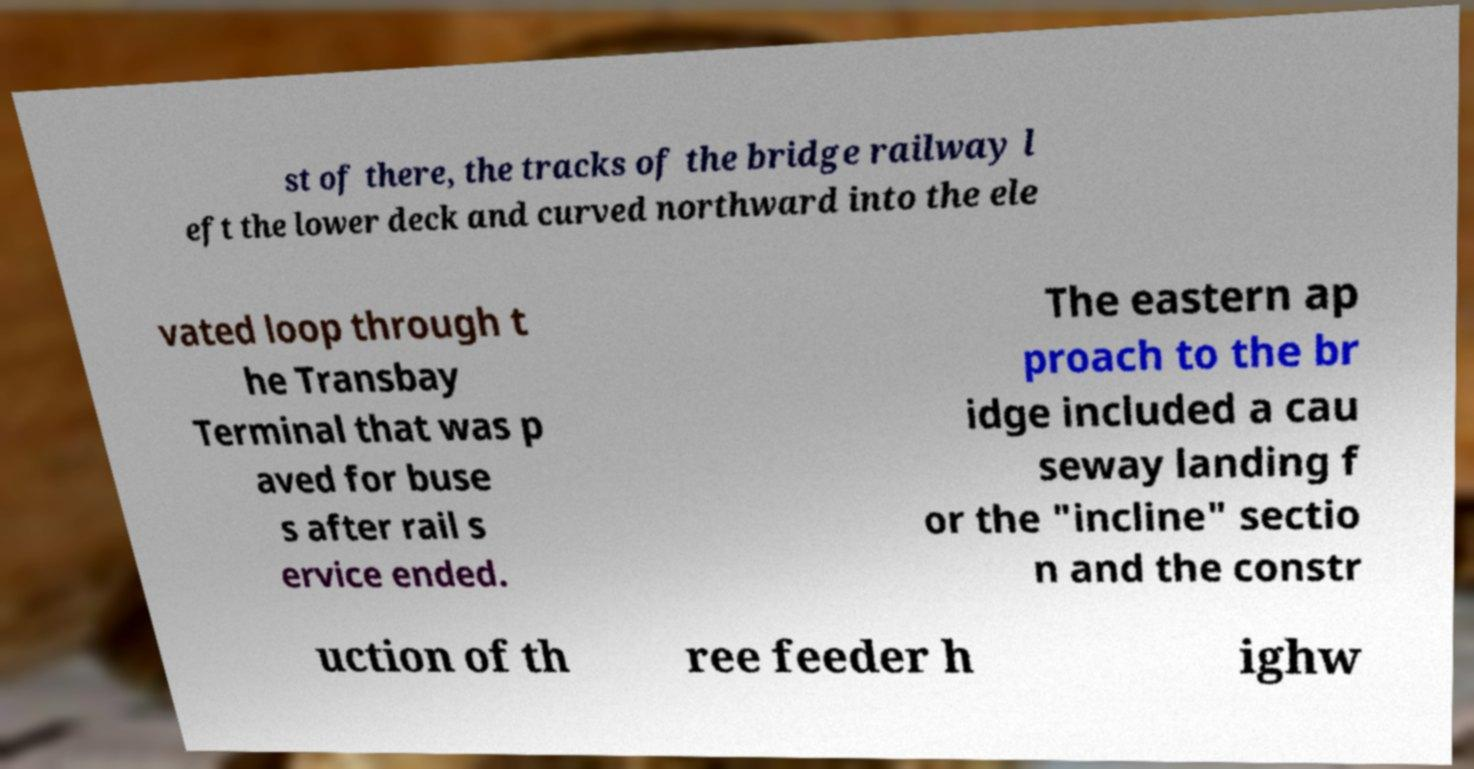There's text embedded in this image that I need extracted. Can you transcribe it verbatim? st of there, the tracks of the bridge railway l eft the lower deck and curved northward into the ele vated loop through t he Transbay Terminal that was p aved for buse s after rail s ervice ended. The eastern ap proach to the br idge included a cau seway landing f or the "incline" sectio n and the constr uction of th ree feeder h ighw 